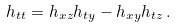<formula> <loc_0><loc_0><loc_500><loc_500>h _ { t t } = h _ { x z } h _ { t y } - h _ { x y } h _ { t z } \, .</formula> 